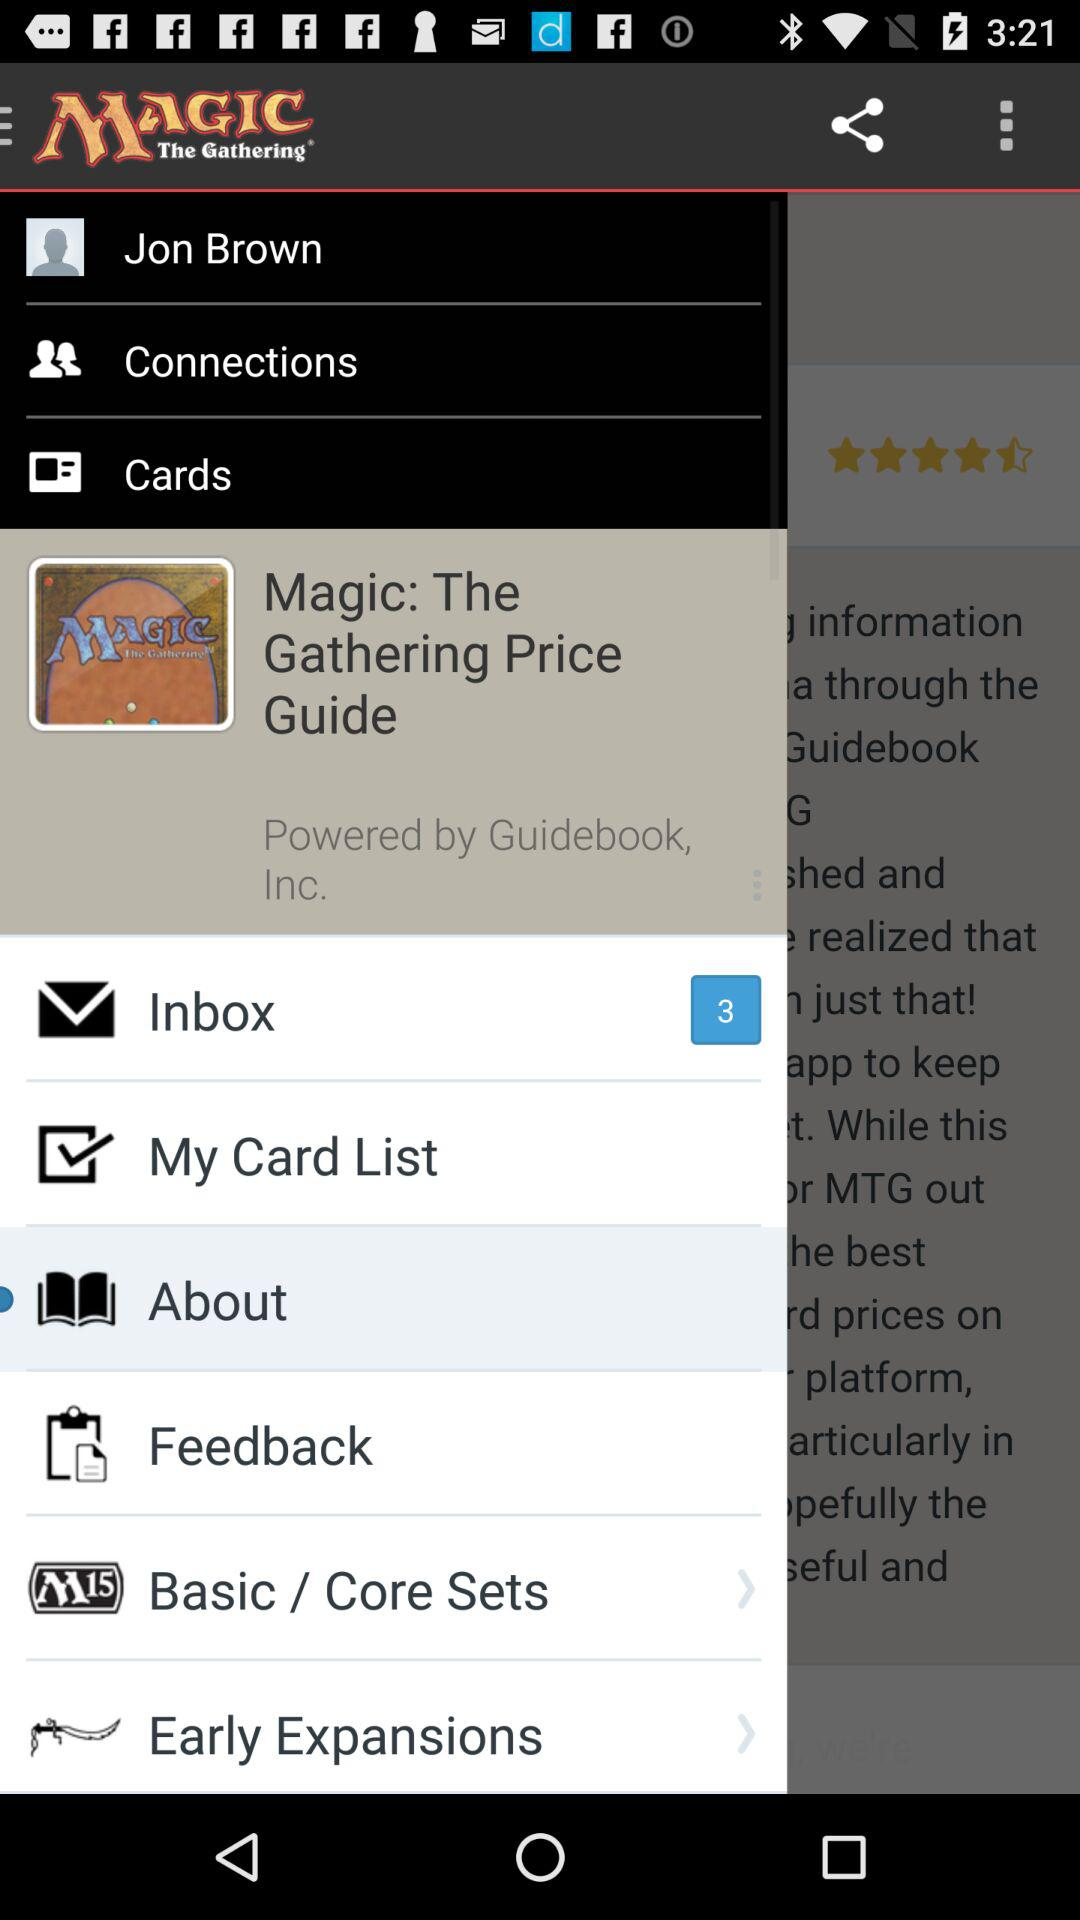What is the user name? The user name is Jon Brown. 